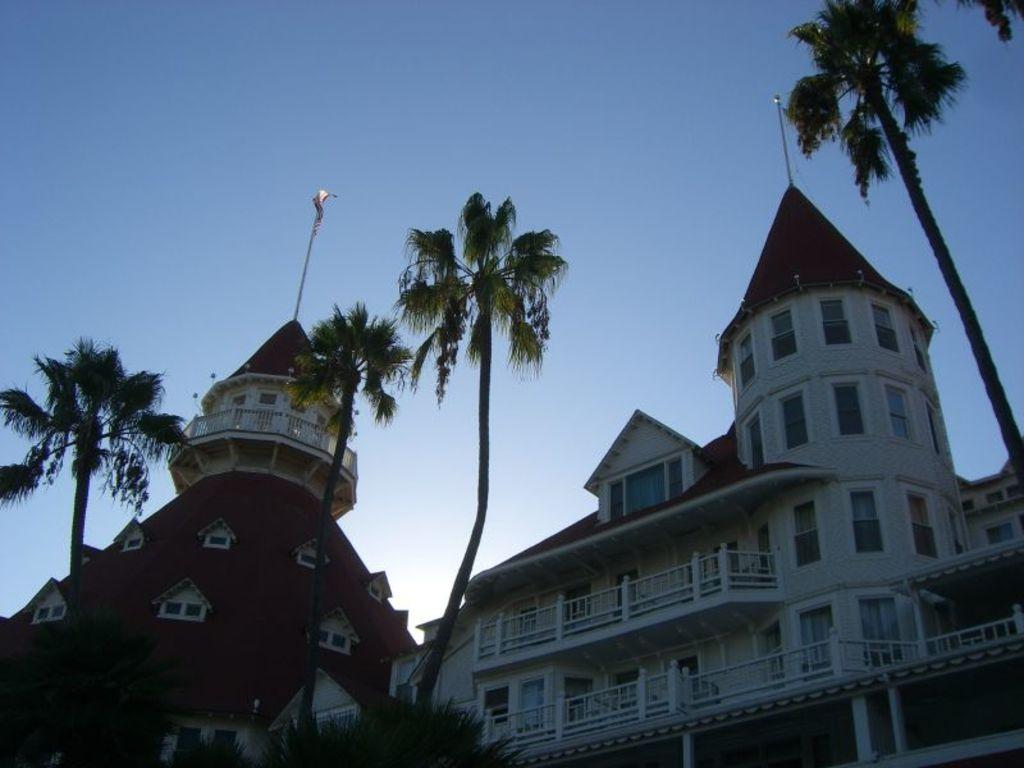What type of vegetation can be seen in the image? There are trees in the image. What type of structure is visible in the background of the image? There is a palace in the background of the image. What part of the natural environment is visible in the image? The sky is visible in the image. Can you hear the sound of the river flowing in the image? There is no river present in the image, so it is not possible to hear the sound of a river flowing. 